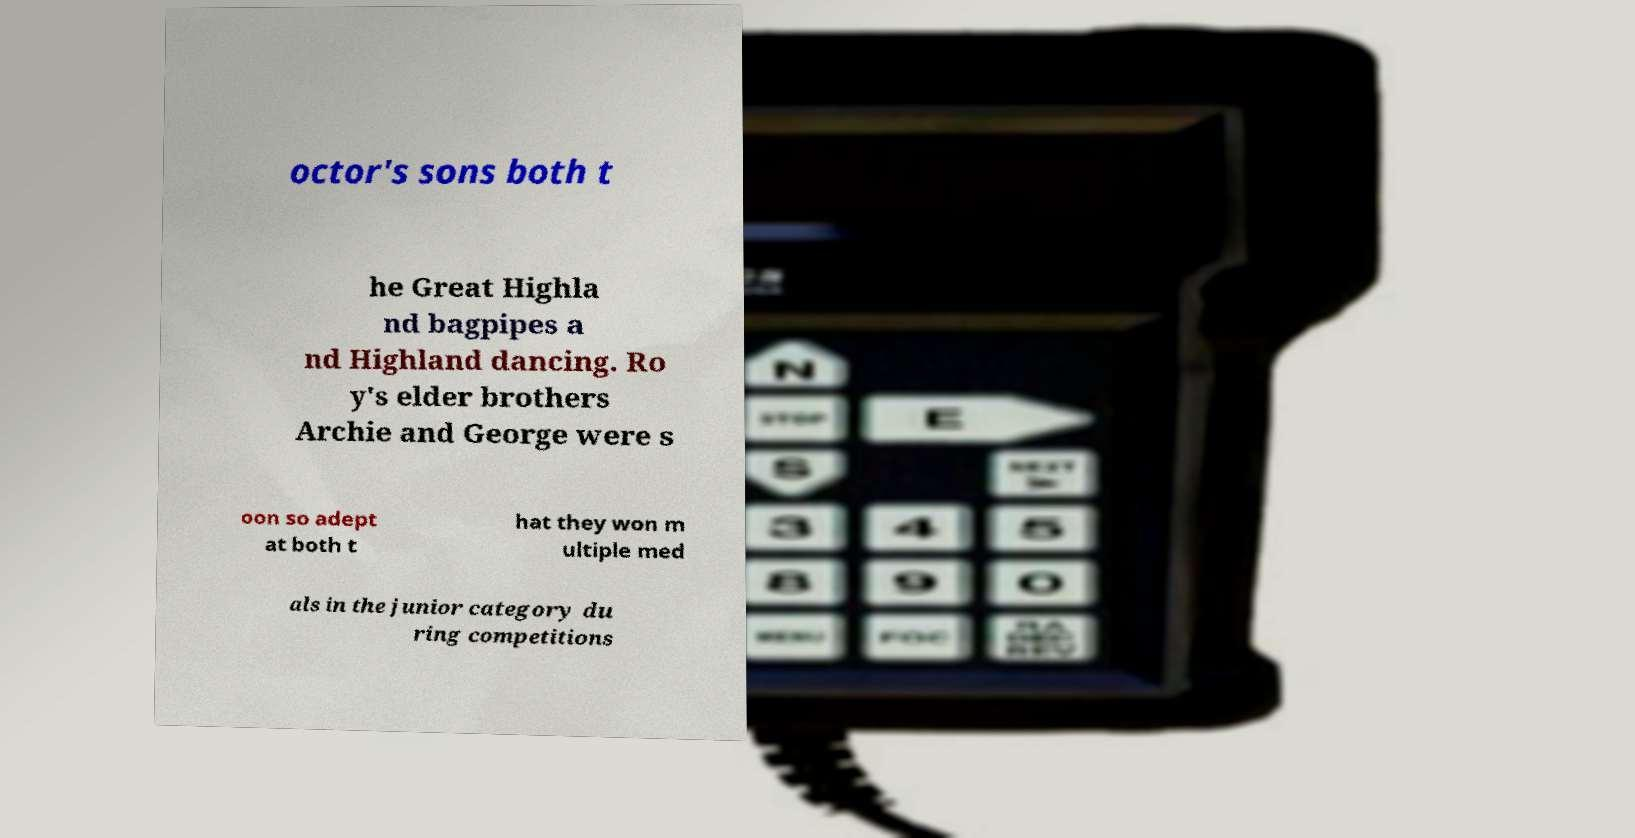Could you assist in decoding the text presented in this image and type it out clearly? octor's sons both t he Great Highla nd bagpipes a nd Highland dancing. Ro y's elder brothers Archie and George were s oon so adept at both t hat they won m ultiple med als in the junior category du ring competitions 